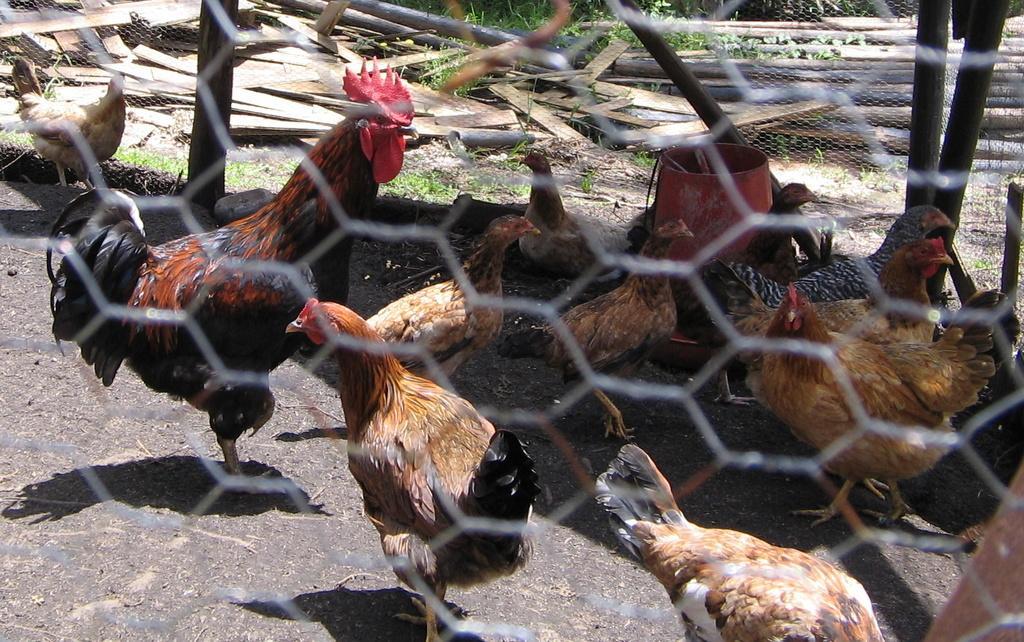Could you give a brief overview of what you see in this image? There are hens and this is mesh. In the background we can see grass and wood. 